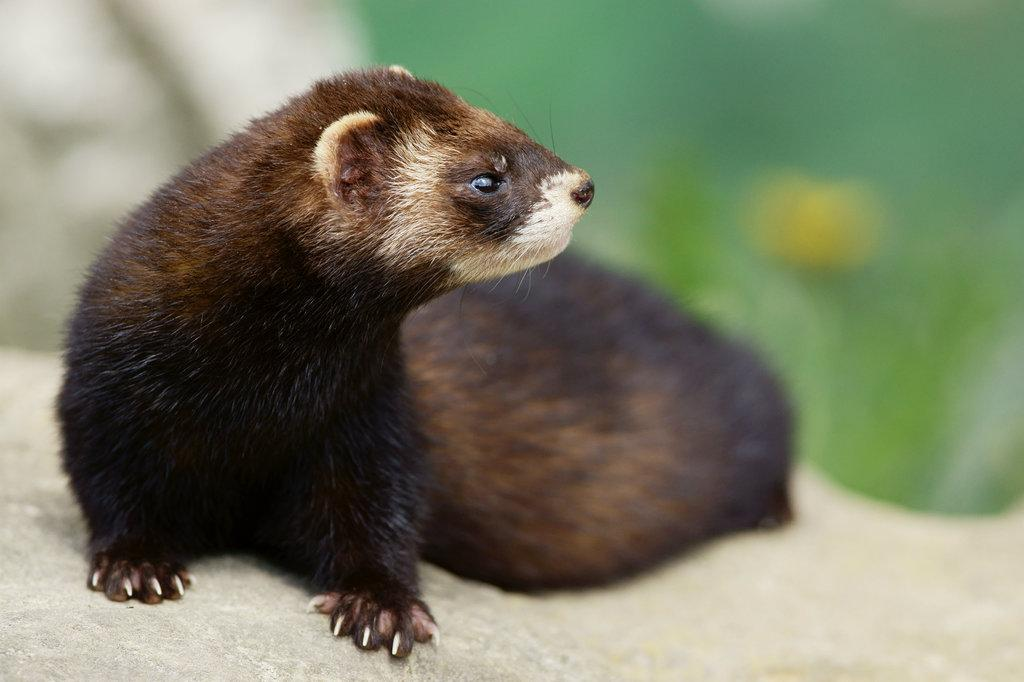What type of animal is in the image? There is a ferret in the image. Where is the ferret located? The ferret is on a surface. Can you describe the background of the image? The background of the image is blurred. What type of jelly can be seen in the image? There is no jelly present in the image; it features a ferret on a surface with a blurred background. 